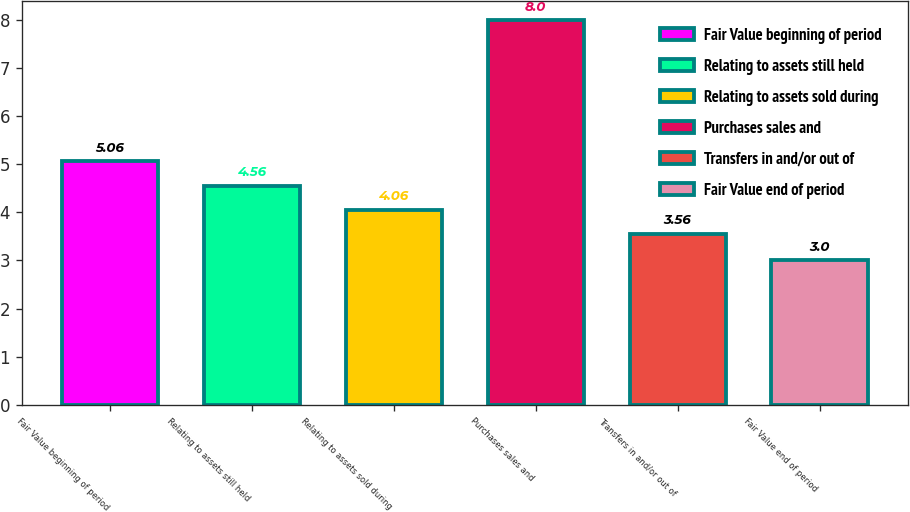<chart> <loc_0><loc_0><loc_500><loc_500><bar_chart><fcel>Fair Value beginning of period<fcel>Relating to assets still held<fcel>Relating to assets sold during<fcel>Purchases sales and<fcel>Transfers in and/or out of<fcel>Fair Value end of period<nl><fcel>5.06<fcel>4.56<fcel>4.06<fcel>8<fcel>3.56<fcel>3<nl></chart> 